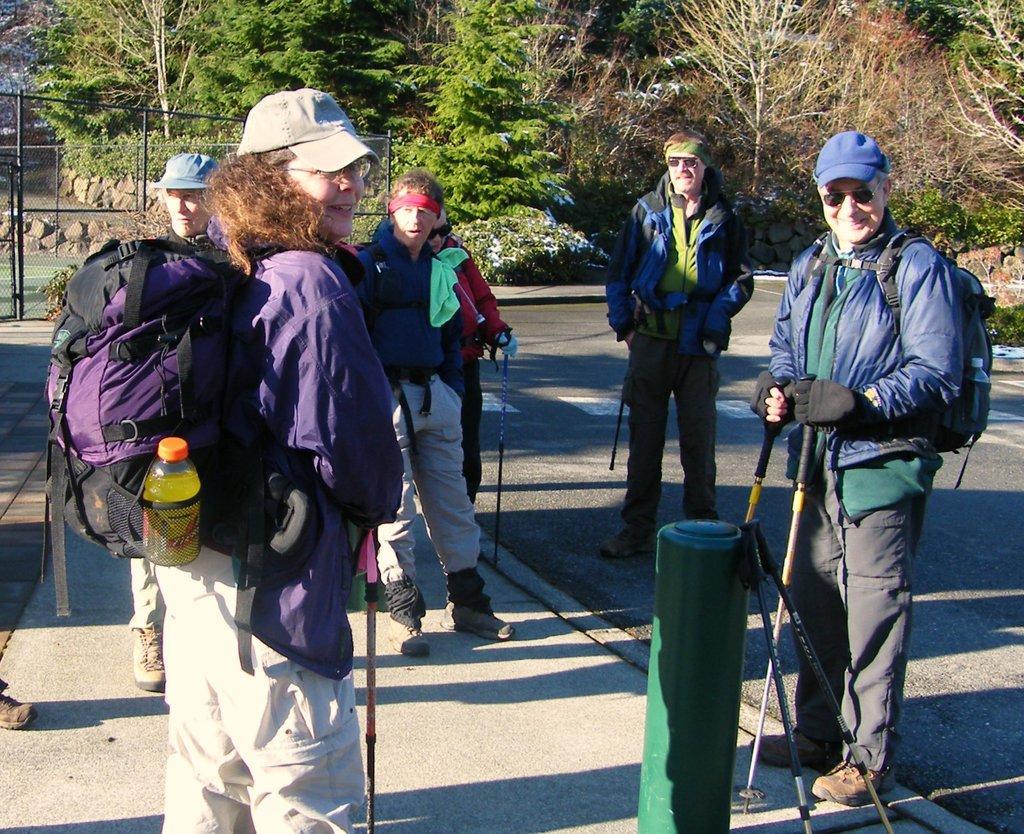How would you summarize this image in a sentence or two? Here we can see a group of people are standing on the road, and here is the travelling bag, and at back here are the trees. 